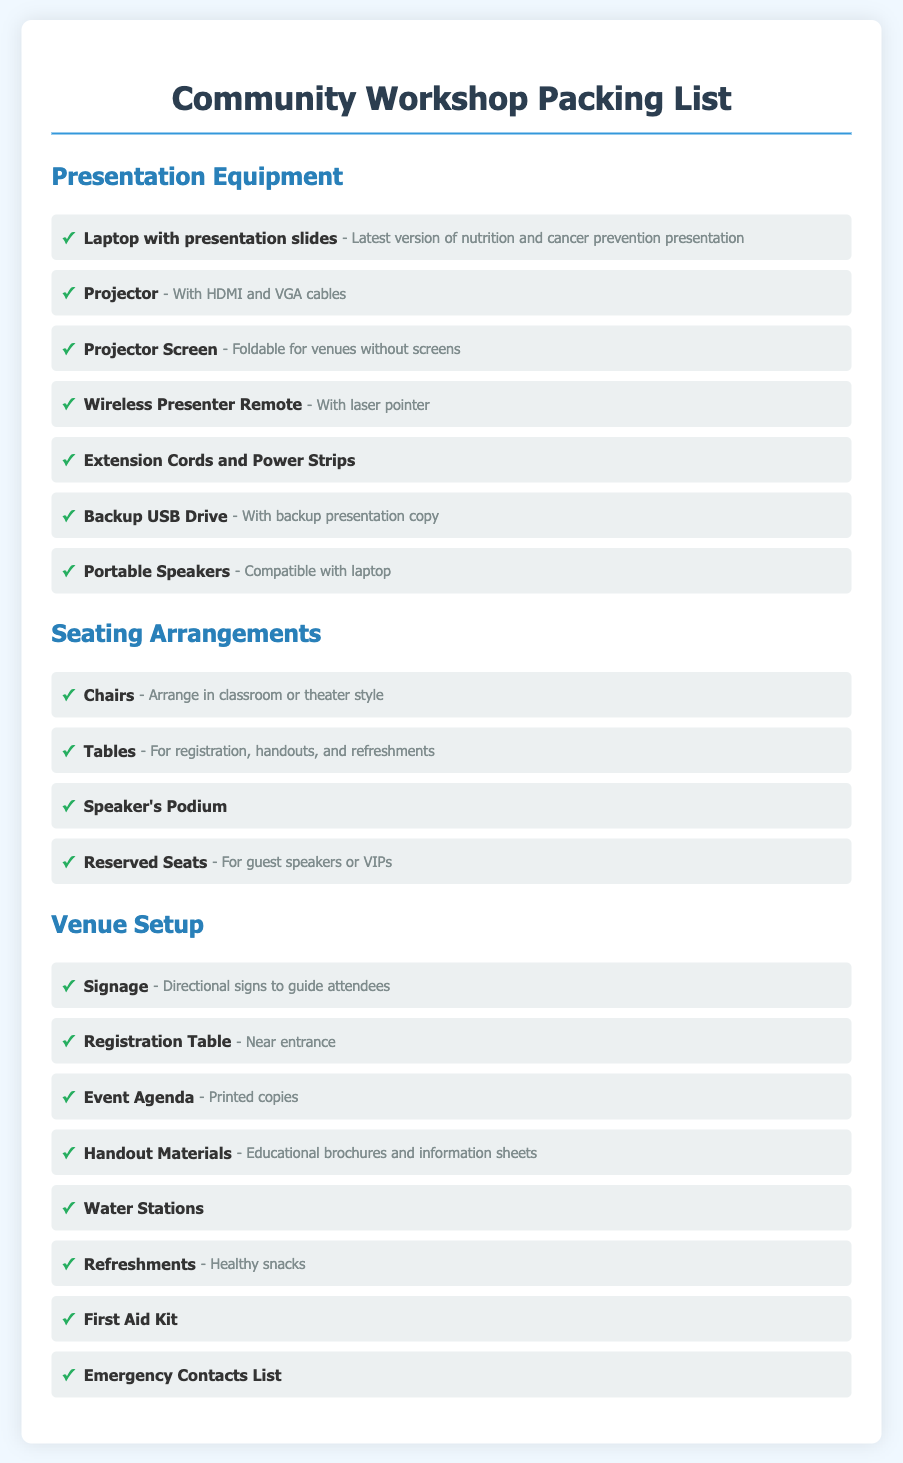what equipment is needed for the presentation? The document lists essential presentation equipment to be used during the workshop.
Answer: Laptop with presentation slides, Projector, Projector Screen, Wireless Presenter Remote, Extension Cords and Power Strips, Backup USB Drive, Portable Speakers how many seating arrangement options are mentioned? The document outlines various seating arrangements that can accommodate attendees during the workshop.
Answer: 4 what must be placed near the entrance? The document specifies a specific setup requirement for the venue.
Answer: Registration Table what types of refreshments are provided? The document describes the nature of the snacks offered during the event.
Answer: Healthy snacks which item is included in the venue setup for emergencies? The document includes a specific item that caters to safety during the workshop.
Answer: First Aid Kit what is required to support guest speakers or VIPs? The document indicates a specific requirement for special seating arrangements during the workshop.
Answer: Reserved Seats how many equipment items are listed for presentation? The document provides a detailed inventory of necessary equipment for effective presentations.
Answer: 7 what materials are included in the handouts? The document specifies the educational resources available to attendees.
Answer: Educational brochures and information sheets who will use the speaker's podium? The document mentions a specific purpose for one of the setup items at the venue.
Answer: Speaker 